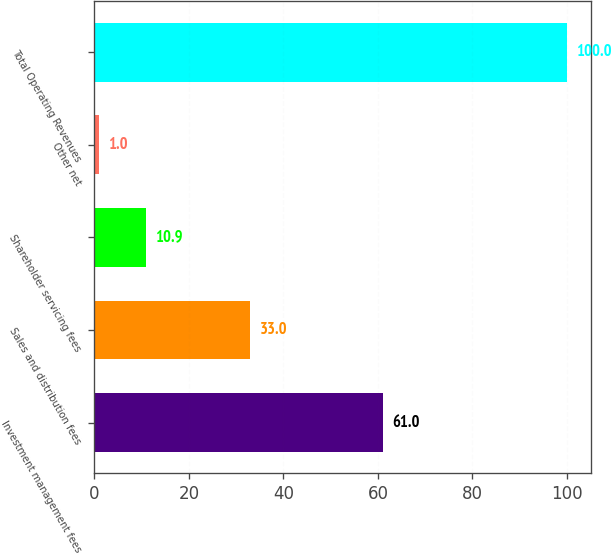Convert chart to OTSL. <chart><loc_0><loc_0><loc_500><loc_500><bar_chart><fcel>Investment management fees<fcel>Sales and distribution fees<fcel>Shareholder servicing fees<fcel>Other net<fcel>Total Operating Revenues<nl><fcel>61<fcel>33<fcel>10.9<fcel>1<fcel>100<nl></chart> 